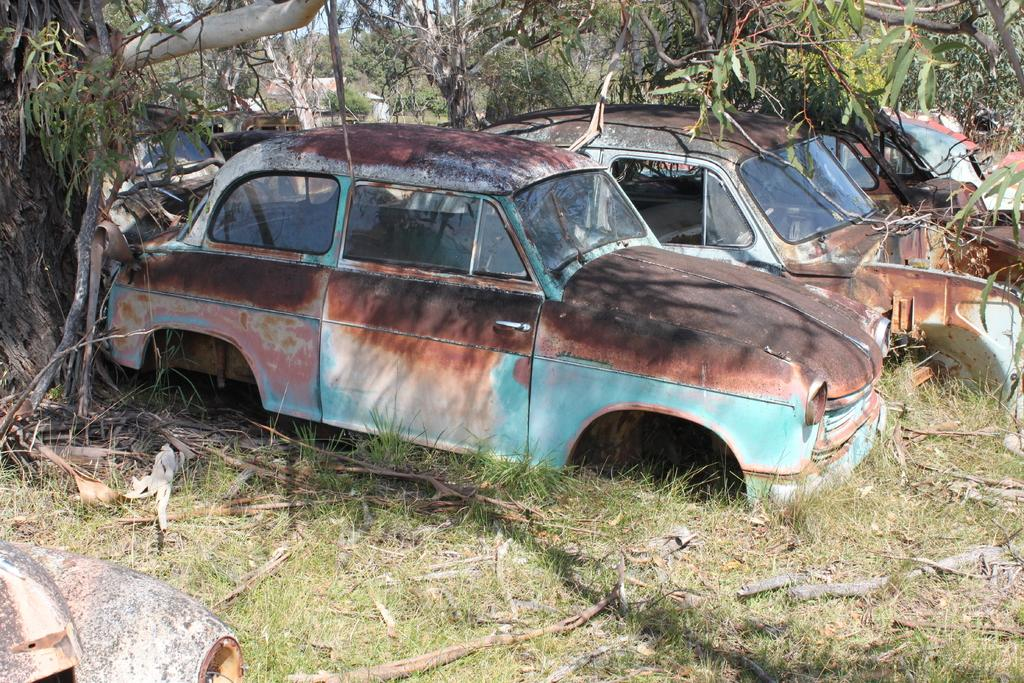What type of objects are depicted in the image? There are scraps of vehicles in the image. Where are the scraps located? The scraps are on a grass surface. What can be seen in the background of the image? There are trees and a part of the sky visible in the background. How many pens can be seen in the image? There are no pens present in the image. What is the noise level in the image? The noise level cannot be determined from the image, as it is a visual medium. 